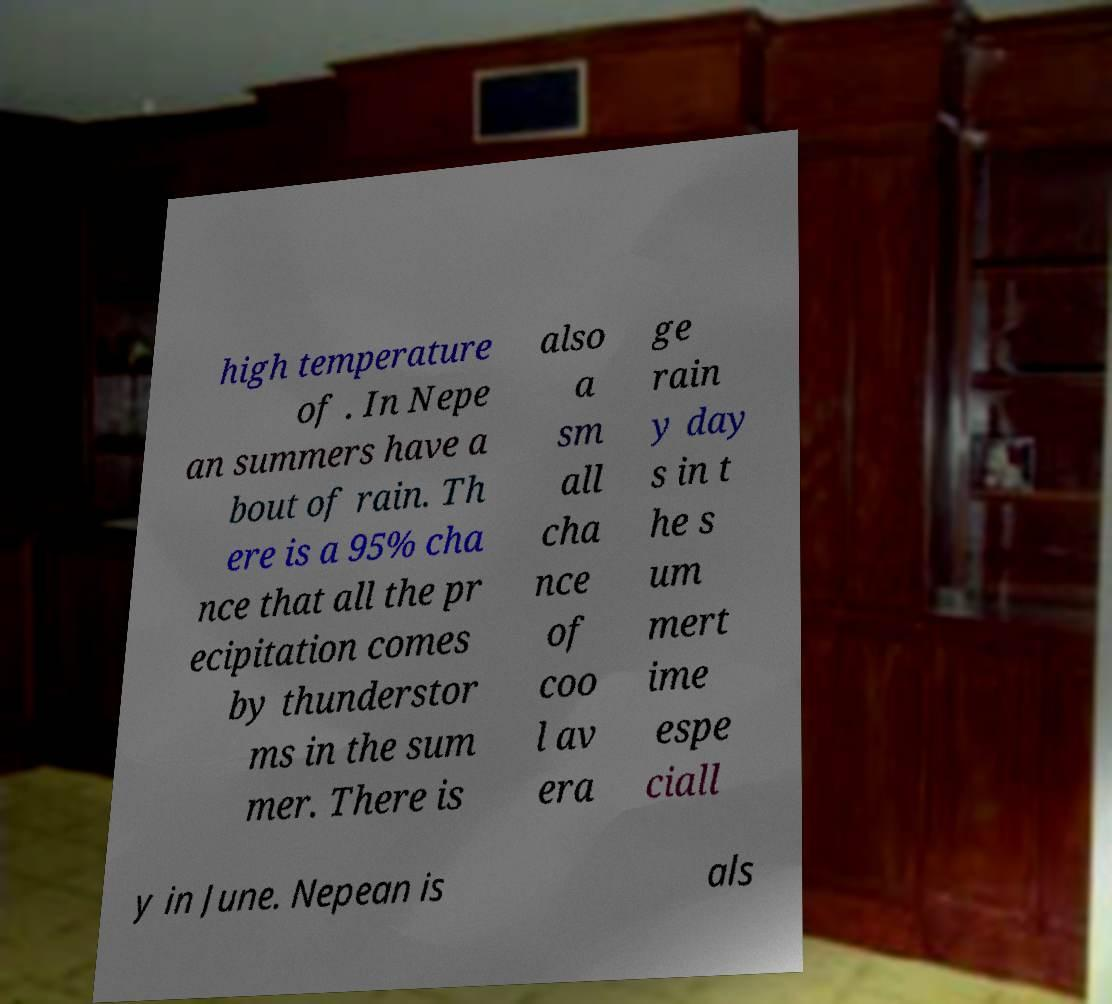Please identify and transcribe the text found in this image. high temperature of . In Nepe an summers have a bout of rain. Th ere is a 95% cha nce that all the pr ecipitation comes by thunderstor ms in the sum mer. There is also a sm all cha nce of coo l av era ge rain y day s in t he s um mert ime espe ciall y in June. Nepean is als 